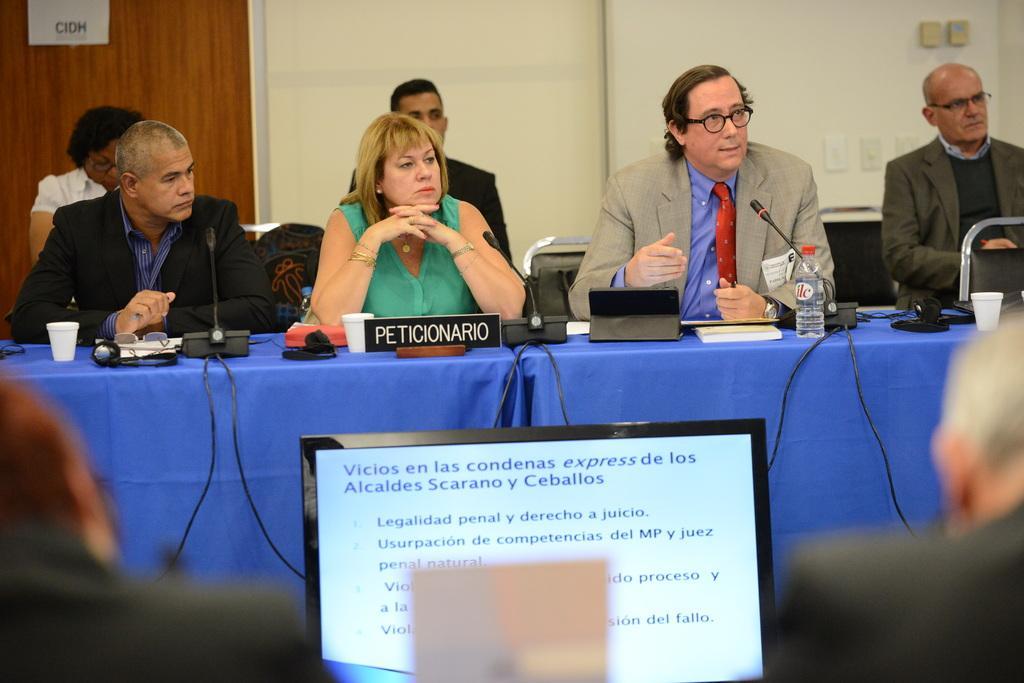Please provide a concise description of this image. In this picture there are group of people sitting. There is a board and there are microphones and there are cups and there are objects on the tables and tables are covered with blue color clothes. In the foreground there is a laptop and there is text on the screen and there are two people sitting. At the back there is a paper on the door and there are objects on the wall. 